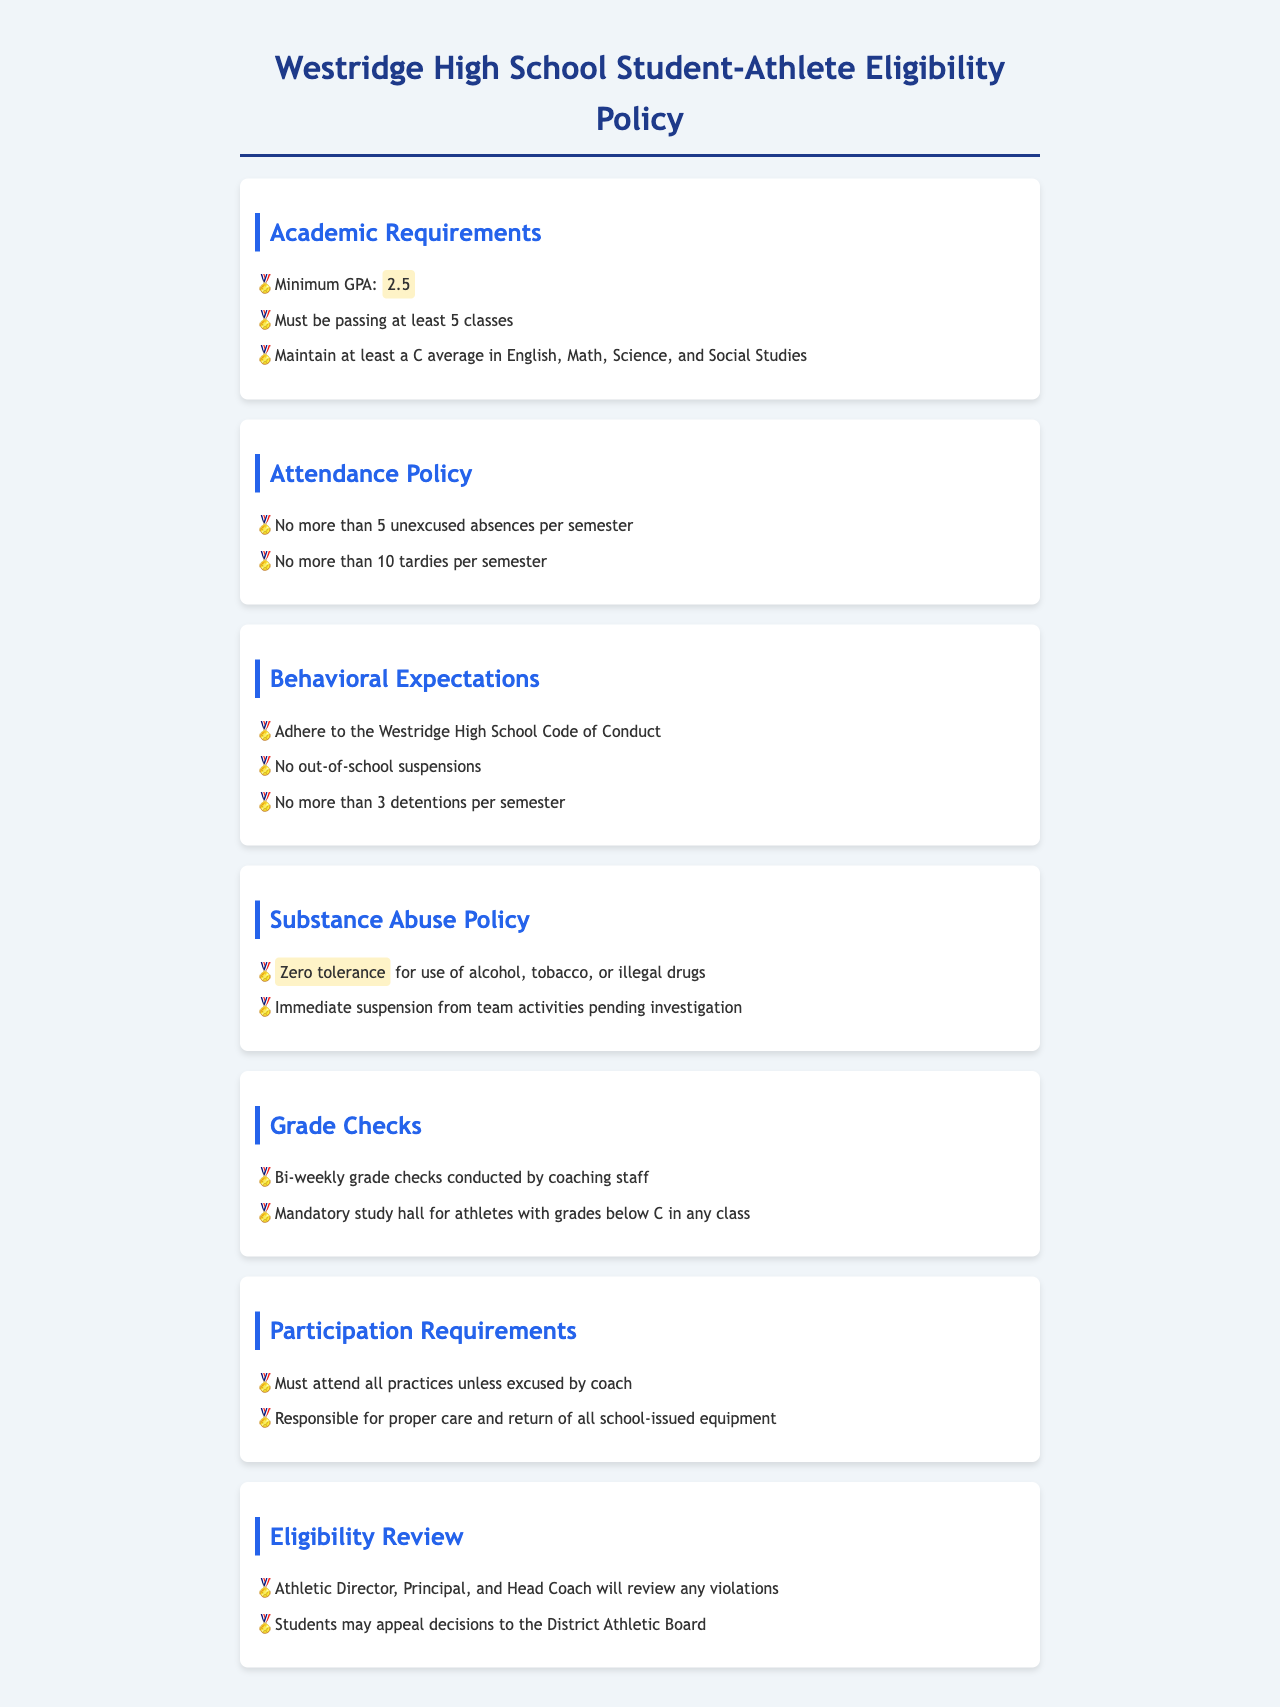What is the minimum GPA required? The minimum GPA required for student-athletes is listed under the Academic Requirements section of the document.
Answer: 2.5 How many classes must a student-athlete be passing? This information is specified in the Academic Requirements section regarding the number of classes student-athletes need to pass.
Answer: 5 classes What is the attendance limit for unexcused absences? The document outlines this limit under the Attendance Policy section, indicating the maximum unexcused absences permitted per semester.
Answer: 5 unexcused absences What is the consequence for substance abuse? The Substance Abuse Policy section details the implication of substance abuse for student-athletes.
Answer: Immediate suspension How often are grade checks conducted? This information can be found in the Grade Checks section specifying the frequency of checks by the coaching staff.
Answer: Bi-weekly What behavioral expectation is set regarding detentions? The Behavioral Expectations section mentions the maximum number of detentions allowed for student-athletes per semester.
Answer: 3 detentions What authority reviews eligibility violations? The Eligibility Review section names the individuals involved in reviewing violations.
Answer: Athletic Director, Principal, and Head Coach What is required for practices attendance? This requirement is specified in the Participation Requirements section regarding attendance rules for student-athletes.
Answer: Must attend all practices unless excused 